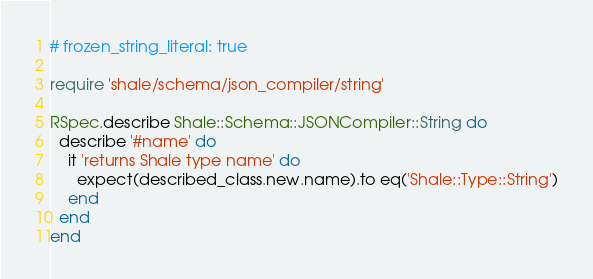<code> <loc_0><loc_0><loc_500><loc_500><_Ruby_># frozen_string_literal: true

require 'shale/schema/json_compiler/string'

RSpec.describe Shale::Schema::JSONCompiler::String do
  describe '#name' do
    it 'returns Shale type name' do
      expect(described_class.new.name).to eq('Shale::Type::String')
    end
  end
end
</code> 